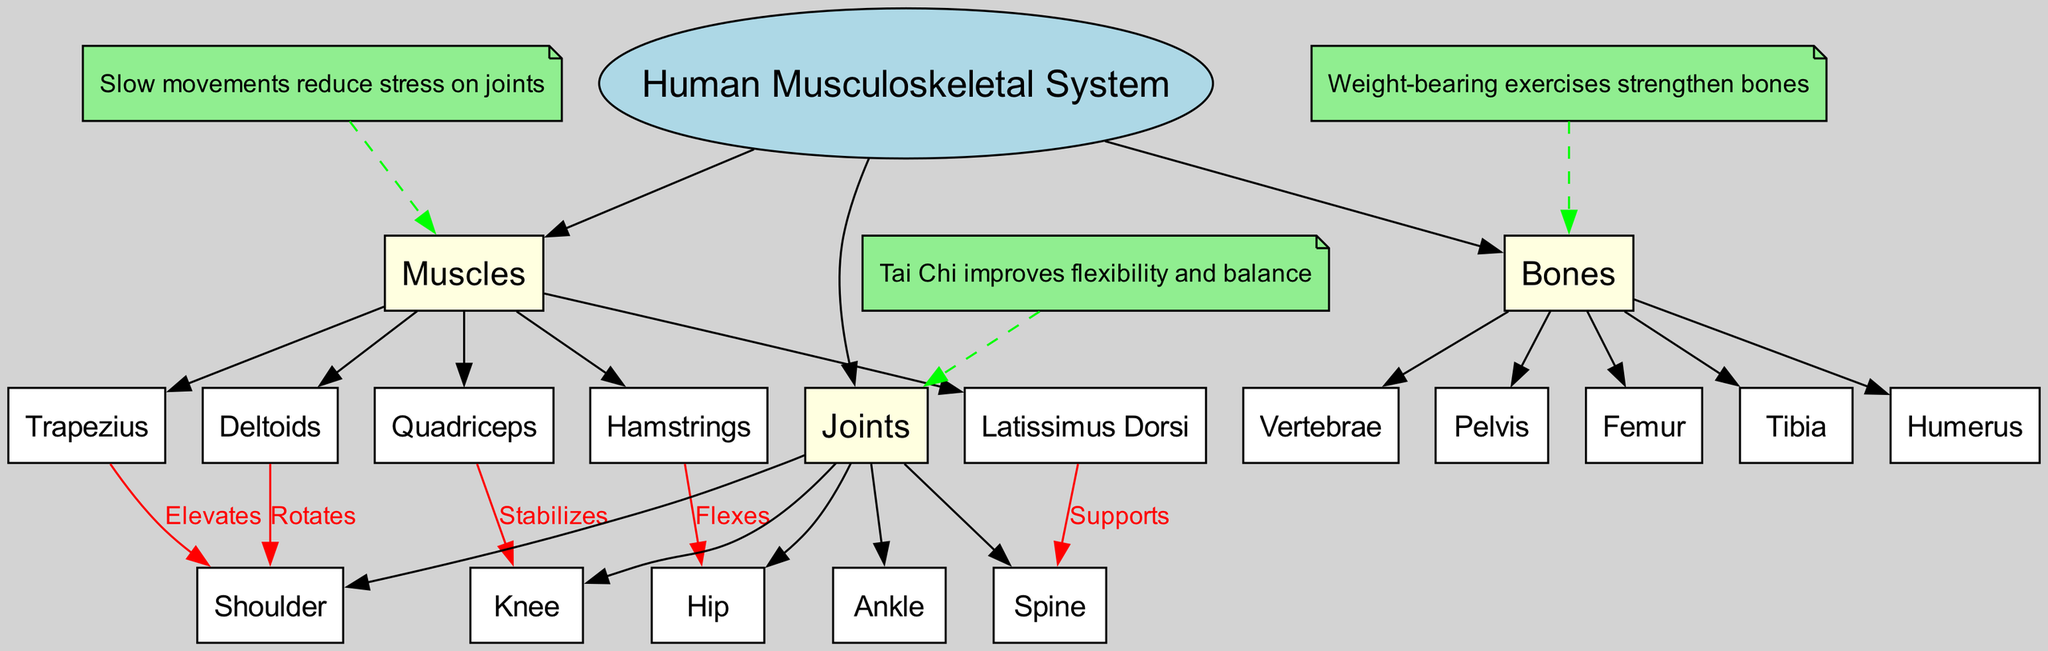What are the major muscle groups labeled in the diagram? The major muscle groups listed in the diagram are categorized under the "Muscles" branch, which includes Quadriceps, Hamstrings, Deltoids, Latissimus Dorsi, and Trapezius.
Answer: Quadriceps, Hamstrings, Deltoids, Latissimus Dorsi, Trapezius How many bones are labeled in the diagram? The "Bones" branch of the diagram contains five subnodes, which are Femur, Tibia, Humerus, Vertebrae, and Pelvis, indicating a total of five bones.
Answer: 5 What joint is associated with the Quadriceps muscle? From the connection labeled in the diagram, it shows that the Quadriceps muscle is connected to the Knee joint, indicating a stabilizing relationship between them.
Answer: Knee Which muscle supports the Spine? According to the connections in the diagram, the Latissimus Dorsi is explicitly labeled as supporting the Spine, thus indicating their relationship.
Answer: Latissimus Dorsi What does Tai Chi improve, based on the notes? The notes section of the diagram mentions that Tai Chi improves flexibility and balance, repeatedly emphasizing its benefits related to the musculoskeletal system.
Answer: Flexibility and balance What movement do the Hamstrings perform at the Hip joint? The diagram indicates that the Hamstrings muscle flexes at the Hip joint, establishing the functional relationship between these anatomical structures.
Answer: Flexes Which muscle elevates the Shoulder joint? The diagram shows that the Trapezius muscle is responsible for elevating the Shoulder joint, illustrating their functional link within the musculoskeletal system.
Answer: Trapezius How does Tai Chi affect stress on muscles? The diagram notes that Tai Chi involves slow movements that reduce stress on muscles, indicating a beneficial aspect of the practice on muscle health.
Answer: Reduces stress Which joint is connected to the Latissimus Dorsi muscle? The connection present in the diagram does not indicate a direct relationship with a joint for the Latissimus Dorsi; rather, it focuses on its support of the Spine, highlighting a unique aspect of its function.
Answer: Spine 